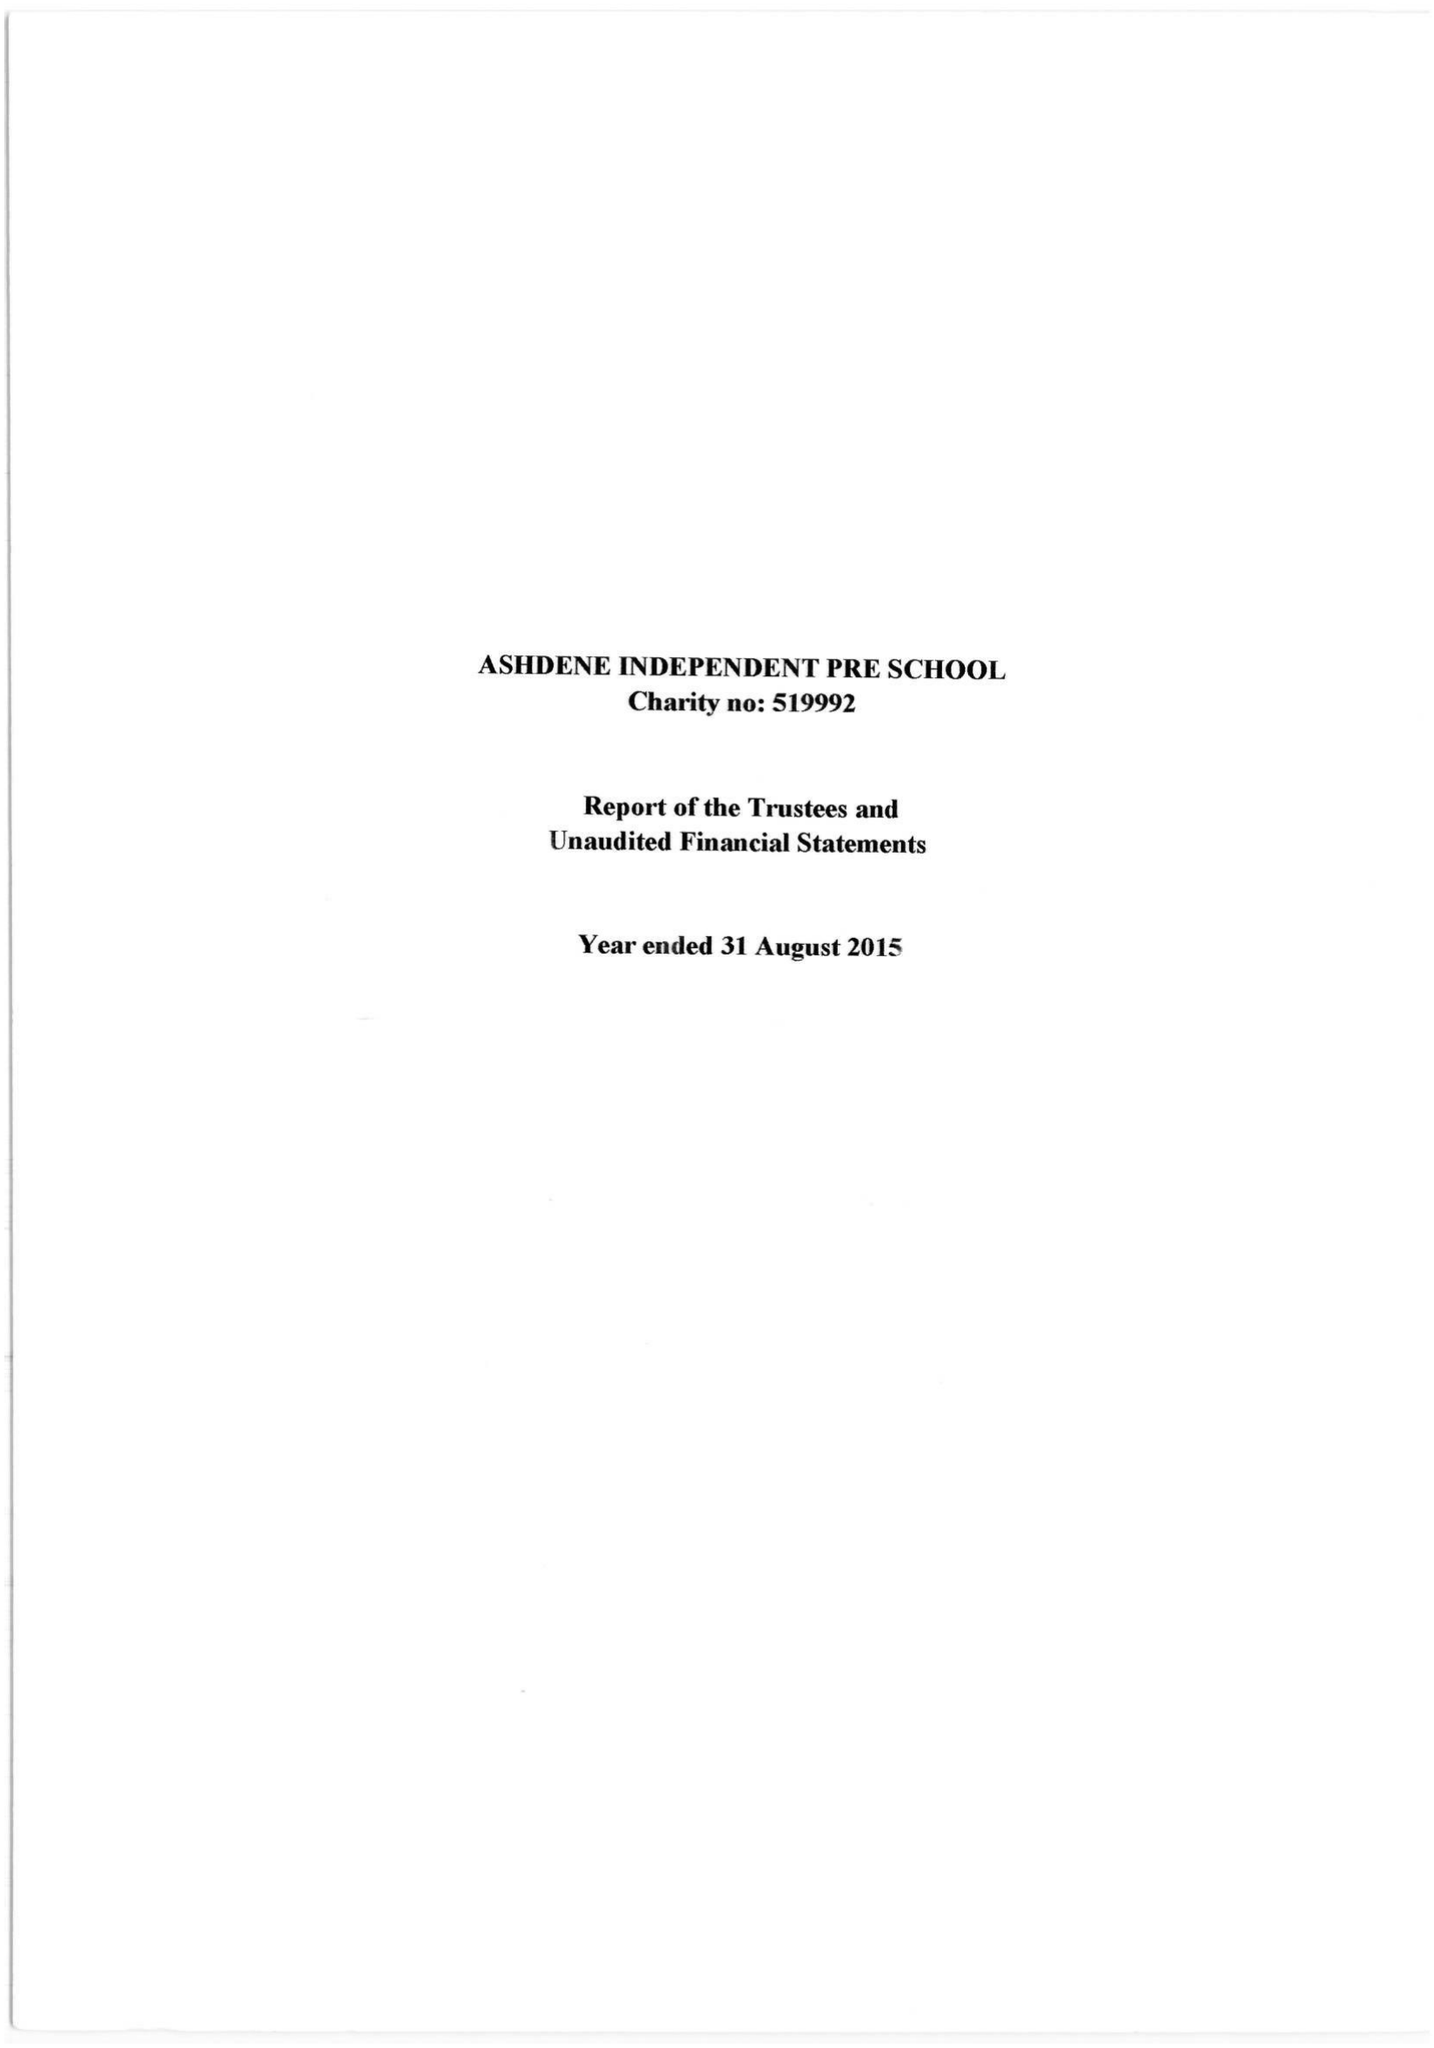What is the value for the spending_annually_in_british_pounds?
Answer the question using a single word or phrase. 171729.00 